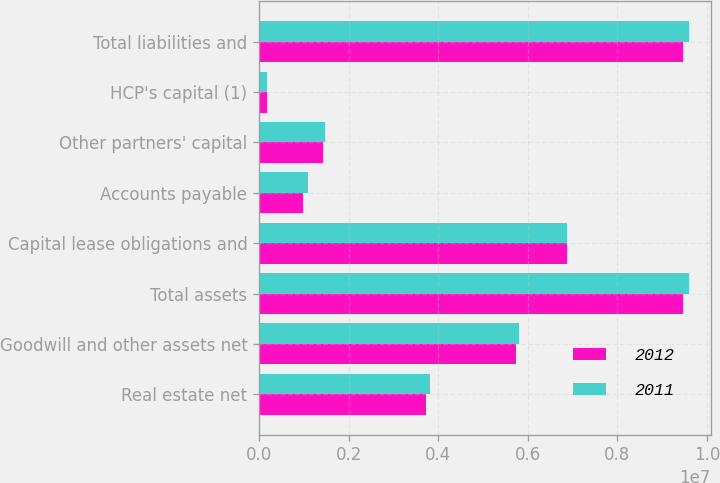<chart> <loc_0><loc_0><loc_500><loc_500><stacked_bar_chart><ecel><fcel>Real estate net<fcel>Goodwill and other assets net<fcel>Total assets<fcel>Capital lease obligations and<fcel>Accounts payable<fcel>Other partners' capital<fcel>HCP's capital (1)<fcel>Total liabilities and<nl><fcel>2012<fcel>3.73174e+06<fcel>5.73432e+06<fcel>9.46606e+06<fcel>6.87593e+06<fcel>971095<fcel>1.43588e+06<fcel>183146<fcel>9.46606e+06<nl><fcel>2011<fcel>3.80619e+06<fcel>5.79769e+06<fcel>9.60388e+06<fcel>6.87174e+06<fcel>1.08358e+06<fcel>1.46554e+06<fcel>183017<fcel>9.60388e+06<nl></chart> 